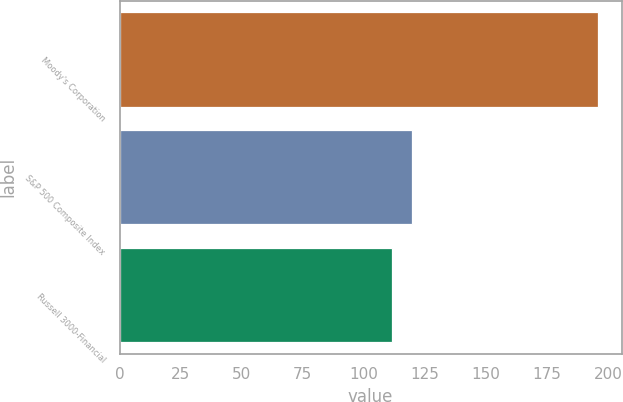Convert chart. <chart><loc_0><loc_0><loc_500><loc_500><bar_chart><fcel>Moody's Corporation<fcel>S&P 500 Composite Index<fcel>Russell 3000-Financial<nl><fcel>195.83<fcel>119.93<fcel>111.5<nl></chart> 